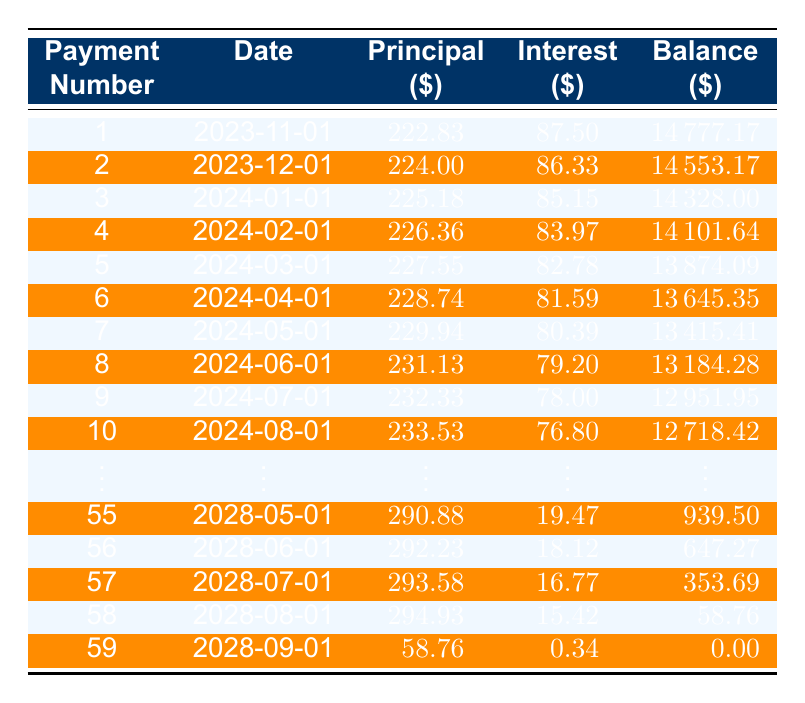What is the total loan amount financed? The table states that the loan amount is $15,000 as provided in the initial data.
Answer: 15000 What is the interest payment of the first month? The first row of the table shows an interest payment of $87.50 for the first payment.
Answer: 87.50 What will the remaining balance be after the 6th payment? According to the 6th payment entry, the remaining balance after the 6th payment is $13,645.35.
Answer: 13645.35 What is the principal payment amount for the 10th month? The table indicates that the principal payment for the 10th month is $233.53.
Answer: 233.53 How much total interest will be paid across all payments? To find the total interest, sum up all monthly interest payments. The total interest paid can be calculated as (87.50 + 86.33 + 85.15 + ... + 0.34), totaling $1,355.64.
Answer: 1355.64 Does the principal payment increase with each payment? Observing the principal payment amounts from the table, we can see that each principal payment is greater than the previous one, indicating this is true.
Answer: Yes What is the average principal payment made over the loan term? The total principal payments over the term need to be calculated and then divided by the number of payments (which is 59). The total principal payments amount to $13,941.52, and averaging this over 59 payments gives an average of $236.52.
Answer: 236.52 In which month will the remaining balance reach less than $3,000? By checking the remaining balances, we find that the balance falls below $3,000 after the 48th payment, where it is $2,945.52.
Answer: 48th payment How much principal is paid off by the end of the loan term? The total principal paid can be measured as the original loan amount minus the remaining balance after the final payment. From the final entry, the remaining amount is $0, indicating the entire loan amount of $15,000 has been paid off.
Answer: 15000 